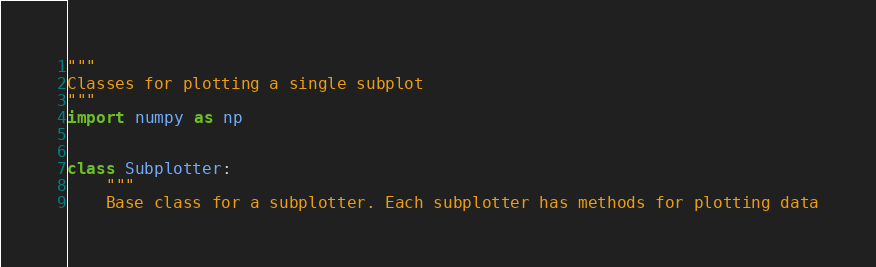Convert code to text. <code><loc_0><loc_0><loc_500><loc_500><_Python_>"""
Classes for plotting a single subplot
"""
import numpy as np


class Subplotter:
    """
    Base class for a subplotter. Each subplotter has methods for plotting data</code> 